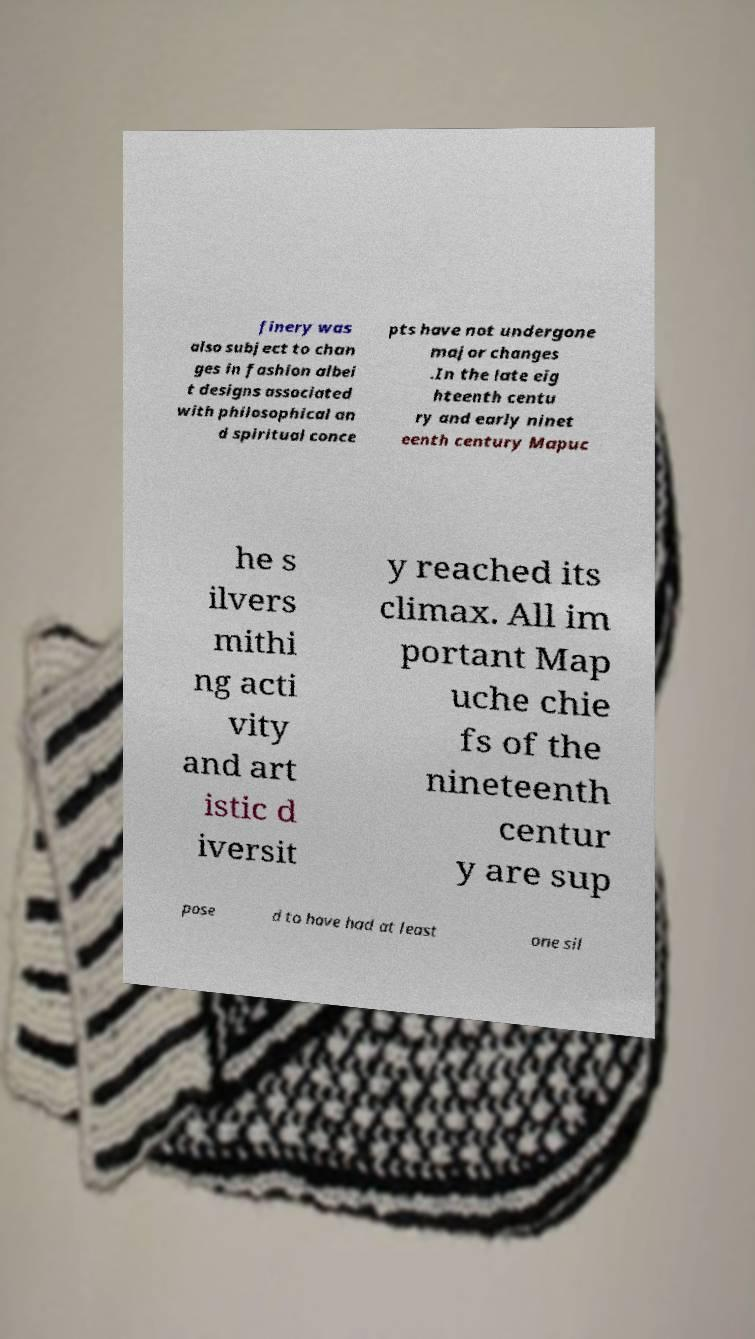Please read and relay the text visible in this image. What does it say? finery was also subject to chan ges in fashion albei t designs associated with philosophical an d spiritual conce pts have not undergone major changes .In the late eig hteenth centu ry and early ninet eenth century Mapuc he s ilvers mithi ng acti vity and art istic d iversit y reached its climax. All im portant Map uche chie fs of the nineteenth centur y are sup pose d to have had at least one sil 